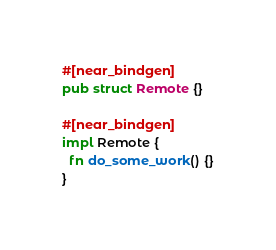Convert code to text. <code><loc_0><loc_0><loc_500><loc_500><_Rust_>
#[near_bindgen]
pub struct Remote {}

#[near_bindgen]
impl Remote {
  fn do_some_work() {}
}</code> 